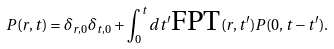Convert formula to latex. <formula><loc_0><loc_0><loc_500><loc_500>P ( r , t ) = \delta _ { r , 0 } \delta _ { t , 0 } + \int _ { 0 } ^ { t } d t ^ { \prime } \text {FPT} ( r , t ^ { \prime } ) P ( 0 , t - t ^ { \prime } ) .</formula> 